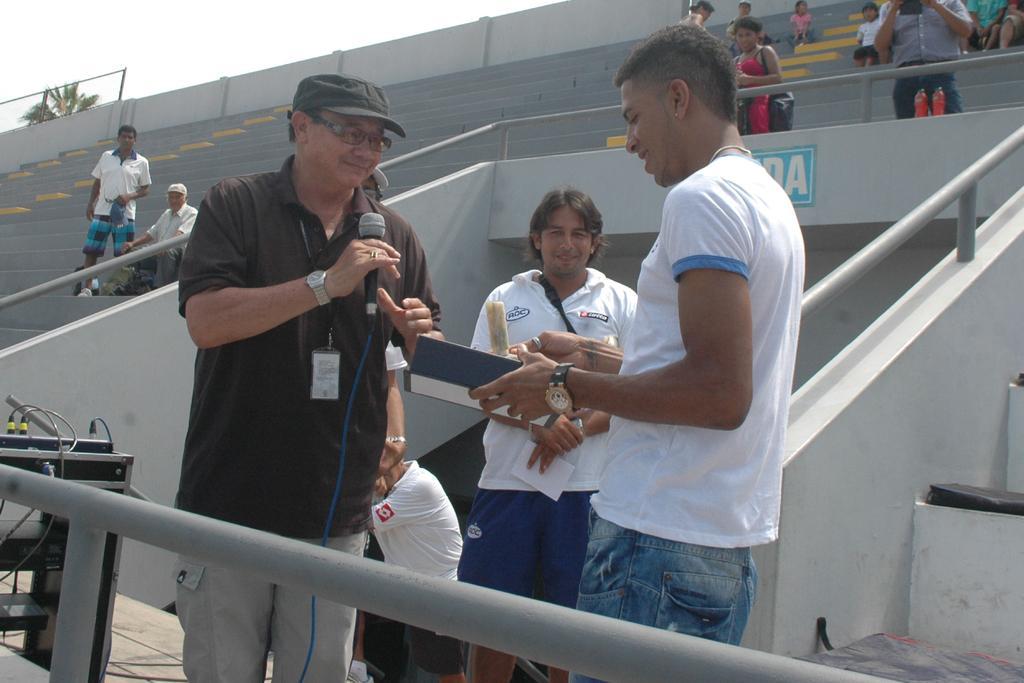Describe this image in one or two sentences. In this image I can see three persons visible and on the left side person he holding a mike and in the middle person he holding a paper and they are smiling , at the top I can see the sky and staircase, on the staircase I can see few persons standing and sitting 